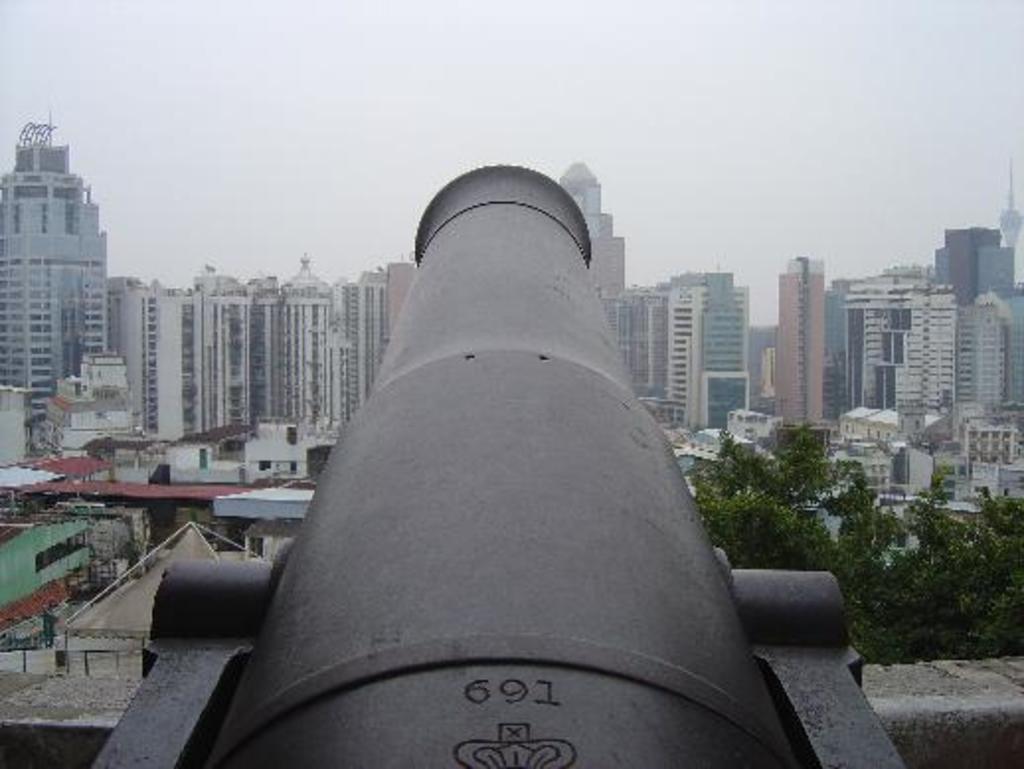How would you summarize this image in a sentence or two? In this image in the front there is a cannon. In the background there are buildings, trees and the sky is cloudy. 